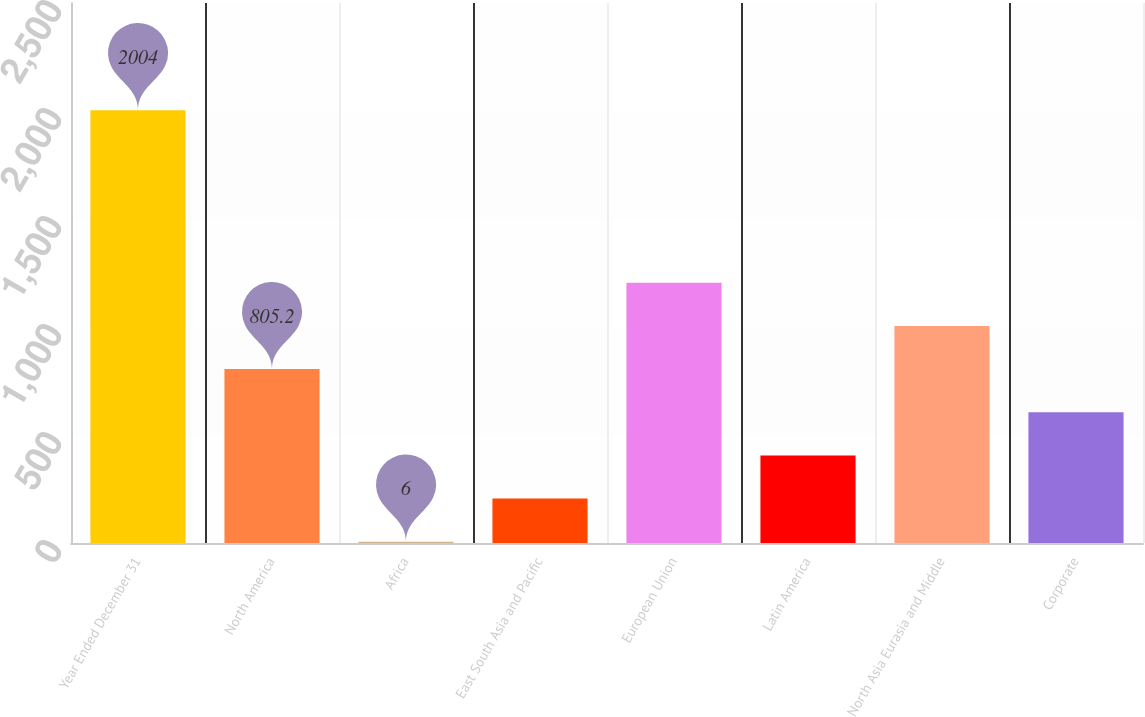<chart> <loc_0><loc_0><loc_500><loc_500><bar_chart><fcel>Year Ended December 31<fcel>North America<fcel>Africa<fcel>East South Asia and Pacific<fcel>European Union<fcel>Latin America<fcel>North Asia Eurasia and Middle<fcel>Corporate<nl><fcel>2004<fcel>805.2<fcel>6<fcel>205.8<fcel>1204.8<fcel>405.6<fcel>1005<fcel>605.4<nl></chart> 